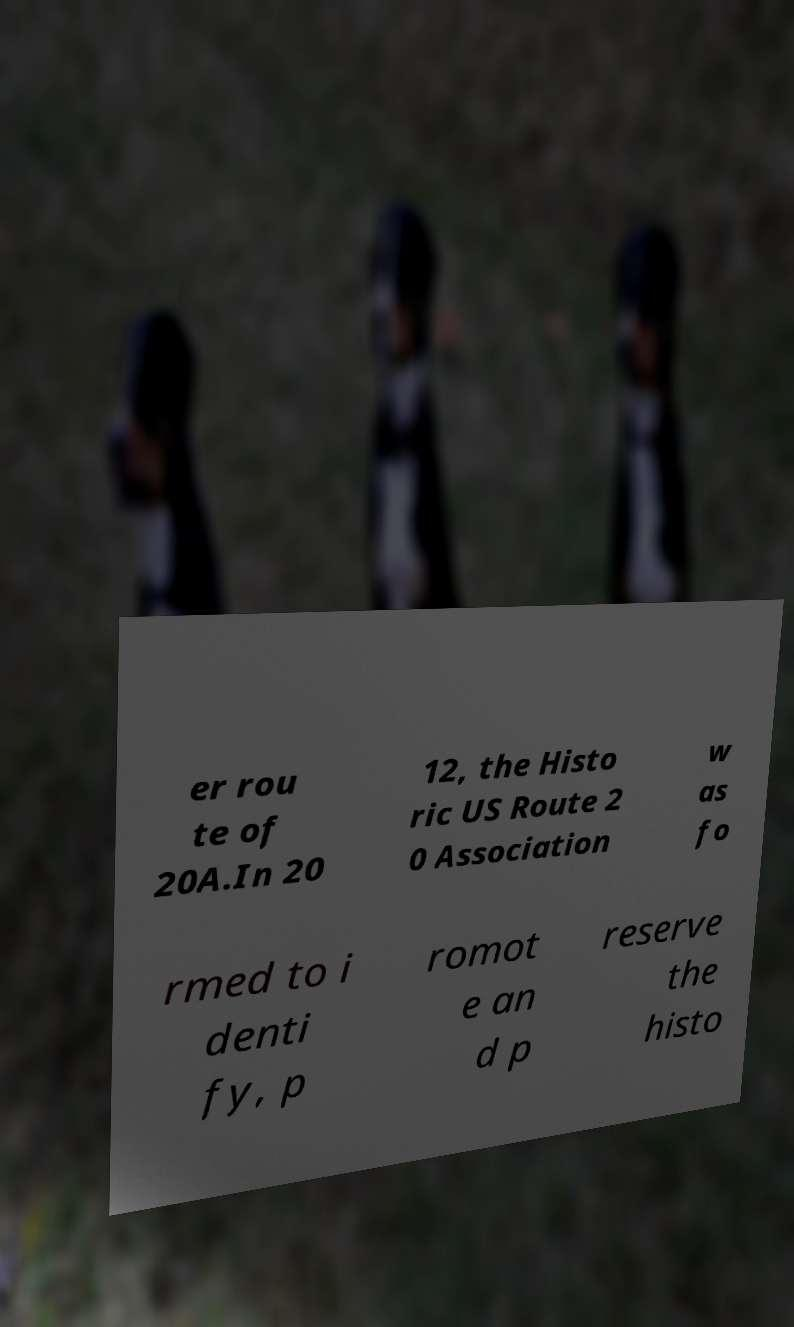I need the written content from this picture converted into text. Can you do that? er rou te of 20A.In 20 12, the Histo ric US Route 2 0 Association w as fo rmed to i denti fy, p romot e an d p reserve the histo 